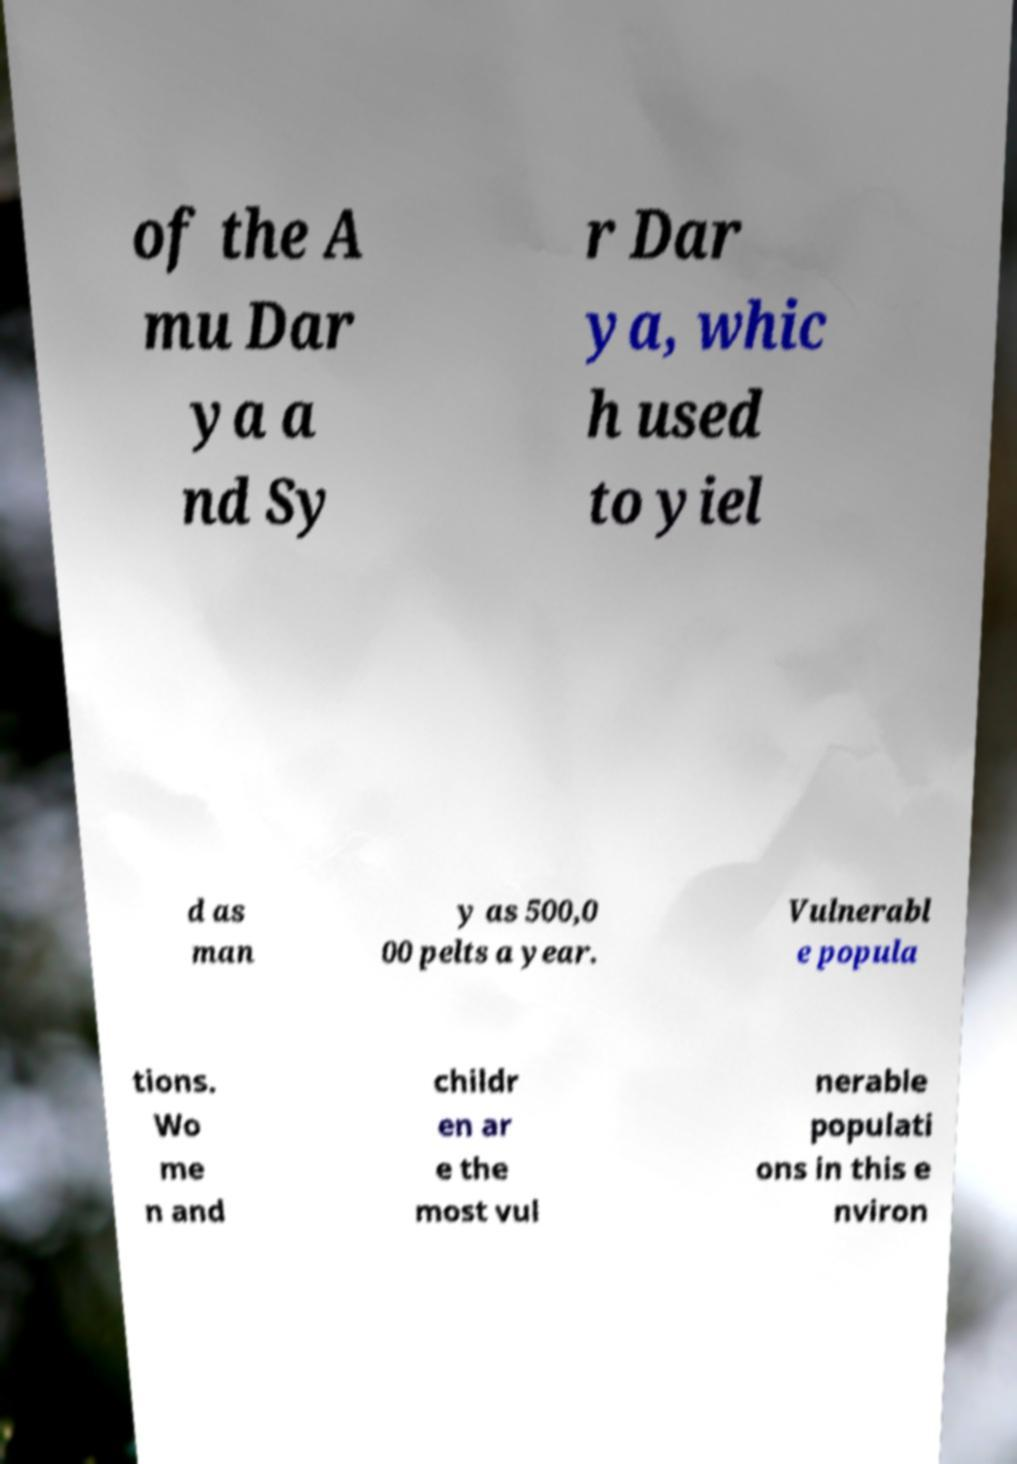Please identify and transcribe the text found in this image. of the A mu Dar ya a nd Sy r Dar ya, whic h used to yiel d as man y as 500,0 00 pelts a year. Vulnerabl e popula tions. Wo me n and childr en ar e the most vul nerable populati ons in this e nviron 